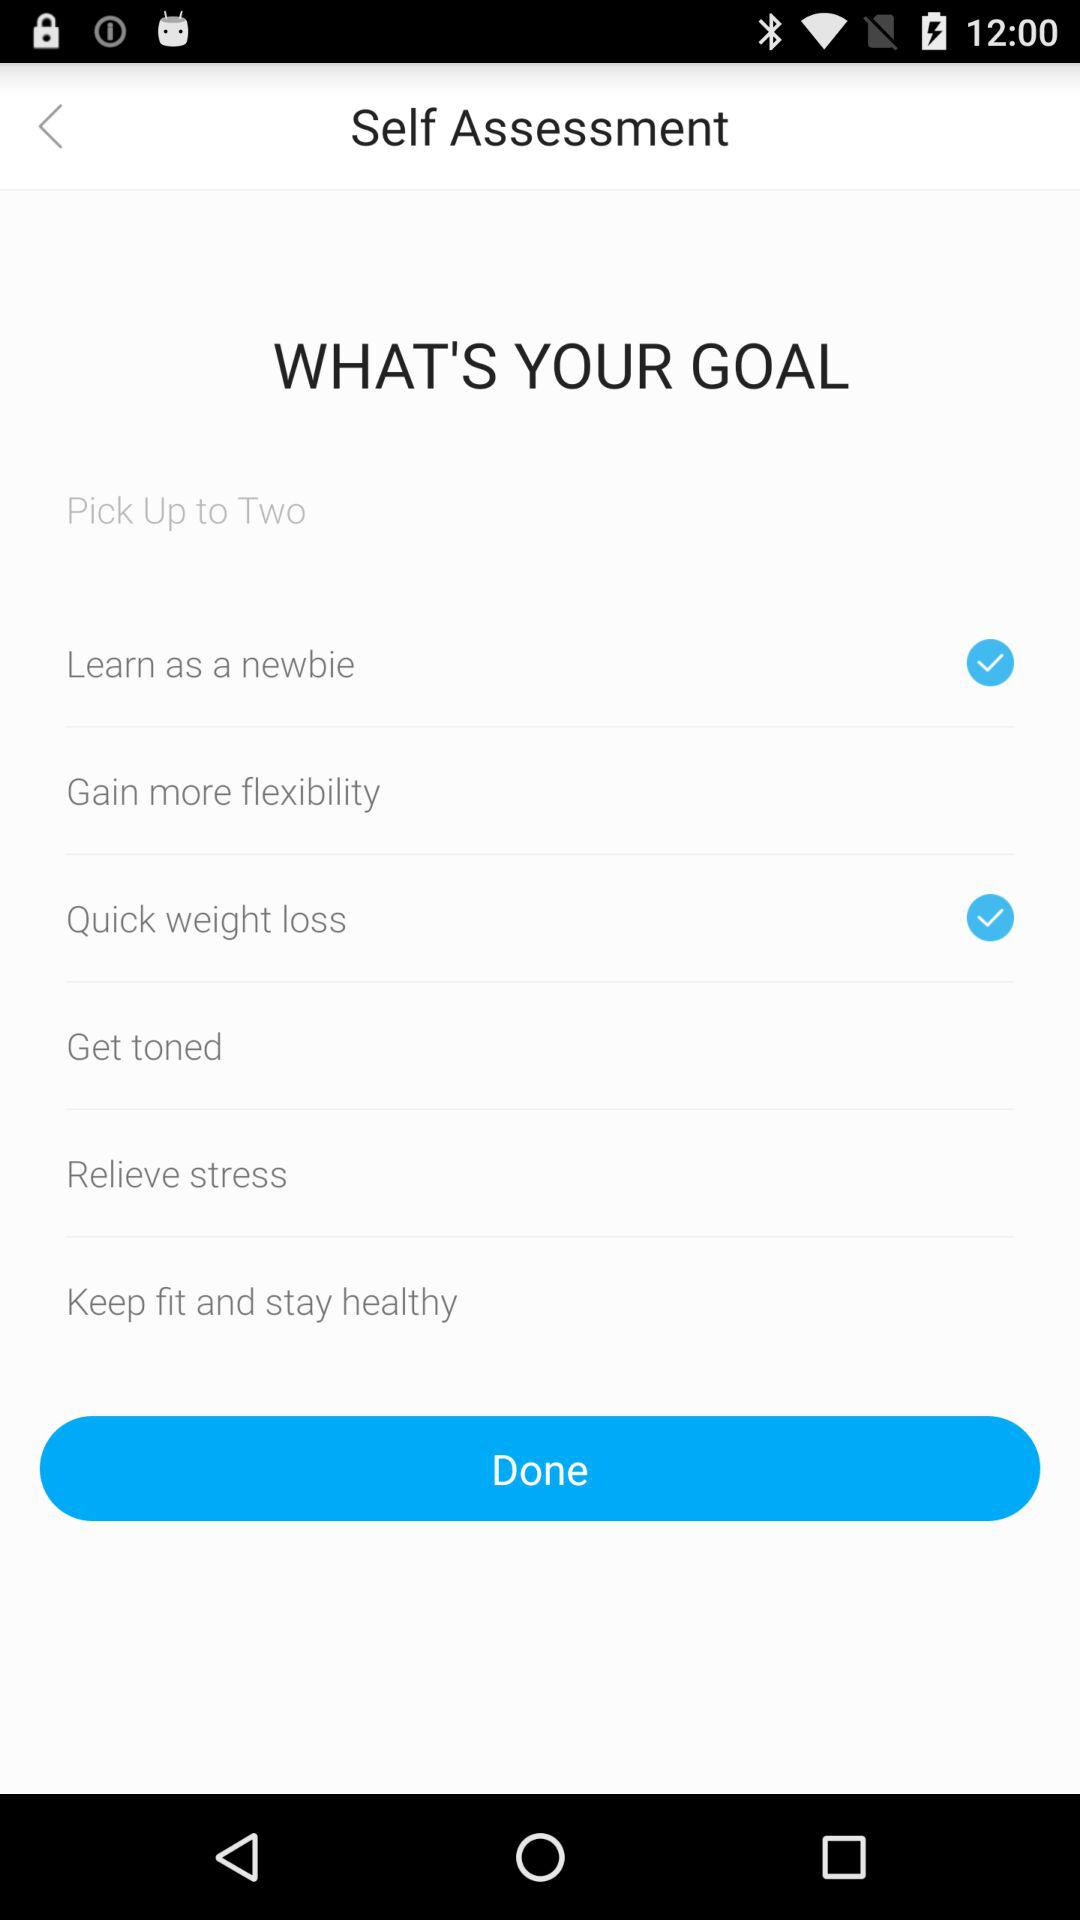Which two options are selected? The two options that are selected are "Learn as a newbie" and "Quick weight loss". 